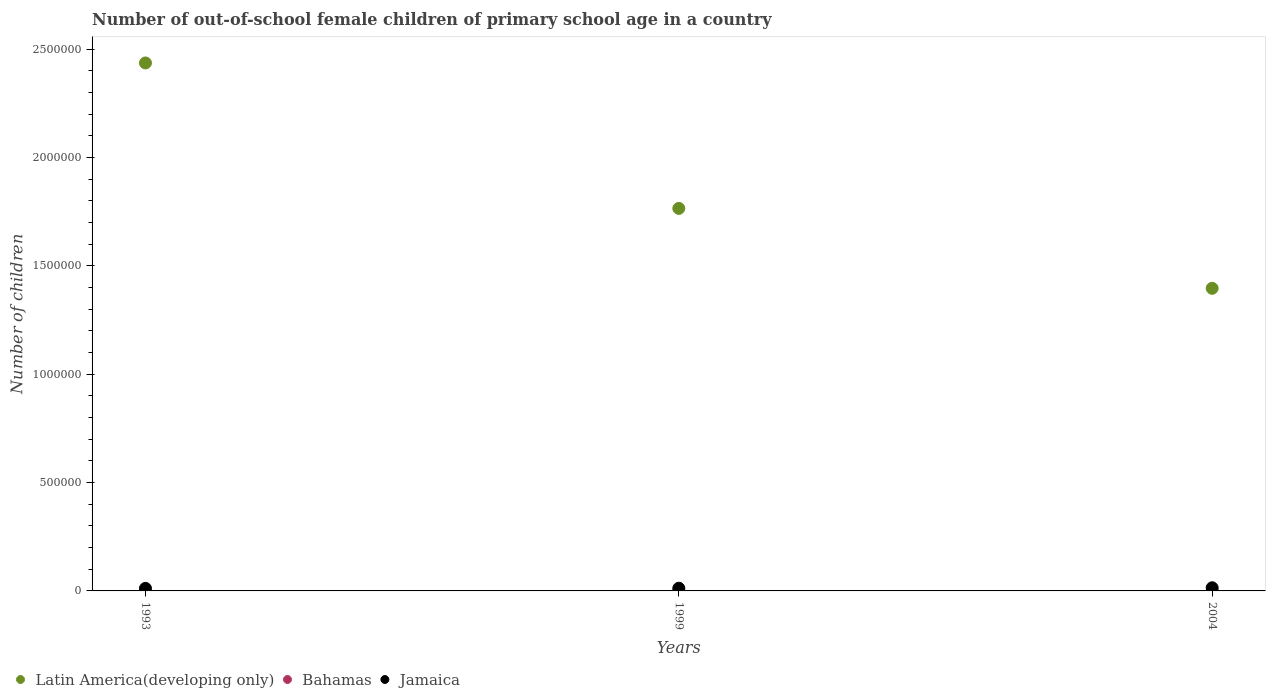Is the number of dotlines equal to the number of legend labels?
Ensure brevity in your answer.  Yes. What is the number of out-of-school female children in Bahamas in 1999?
Give a very brief answer. 1607. Across all years, what is the maximum number of out-of-school female children in Latin America(developing only)?
Make the answer very short. 2.44e+06. Across all years, what is the minimum number of out-of-school female children in Jamaica?
Offer a very short reply. 1.17e+04. What is the total number of out-of-school female children in Latin America(developing only) in the graph?
Your answer should be very brief. 5.60e+06. What is the difference between the number of out-of-school female children in Bahamas in 1993 and that in 2004?
Your response must be concise. 991. What is the difference between the number of out-of-school female children in Latin America(developing only) in 1993 and the number of out-of-school female children in Bahamas in 2004?
Offer a terse response. 2.44e+06. What is the average number of out-of-school female children in Bahamas per year?
Provide a short and direct response. 1398. In the year 1999, what is the difference between the number of out-of-school female children in Latin America(developing only) and number of out-of-school female children in Bahamas?
Provide a short and direct response. 1.76e+06. What is the ratio of the number of out-of-school female children in Latin America(developing only) in 1993 to that in 1999?
Your response must be concise. 1.38. Is the number of out-of-school female children in Latin America(developing only) in 1993 less than that in 1999?
Offer a terse response. No. What is the difference between the highest and the second highest number of out-of-school female children in Jamaica?
Your answer should be compact. 2167. What is the difference between the highest and the lowest number of out-of-school female children in Latin America(developing only)?
Ensure brevity in your answer.  1.04e+06. In how many years, is the number of out-of-school female children in Bahamas greater than the average number of out-of-school female children in Bahamas taken over all years?
Your response must be concise. 2. Is the sum of the number of out-of-school female children in Latin America(developing only) in 1993 and 1999 greater than the maximum number of out-of-school female children in Bahamas across all years?
Your answer should be very brief. Yes. What is the difference between two consecutive major ticks on the Y-axis?
Your answer should be very brief. 5.00e+05. Are the values on the major ticks of Y-axis written in scientific E-notation?
Offer a very short reply. No. Does the graph contain any zero values?
Provide a succinct answer. No. Does the graph contain grids?
Provide a short and direct response. No. How are the legend labels stacked?
Your answer should be compact. Horizontal. What is the title of the graph?
Provide a succinct answer. Number of out-of-school female children of primary school age in a country. What is the label or title of the X-axis?
Your response must be concise. Years. What is the label or title of the Y-axis?
Keep it short and to the point. Number of children. What is the Number of children in Latin America(developing only) in 1993?
Your answer should be compact. 2.44e+06. What is the Number of children of Bahamas in 1993?
Your answer should be compact. 1789. What is the Number of children in Jamaica in 1993?
Provide a short and direct response. 1.17e+04. What is the Number of children of Latin America(developing only) in 1999?
Your answer should be very brief. 1.77e+06. What is the Number of children in Bahamas in 1999?
Ensure brevity in your answer.  1607. What is the Number of children in Jamaica in 1999?
Your response must be concise. 1.24e+04. What is the Number of children in Latin America(developing only) in 2004?
Provide a short and direct response. 1.40e+06. What is the Number of children in Bahamas in 2004?
Give a very brief answer. 798. What is the Number of children in Jamaica in 2004?
Your answer should be compact. 1.46e+04. Across all years, what is the maximum Number of children of Latin America(developing only)?
Your answer should be very brief. 2.44e+06. Across all years, what is the maximum Number of children in Bahamas?
Provide a short and direct response. 1789. Across all years, what is the maximum Number of children in Jamaica?
Keep it short and to the point. 1.46e+04. Across all years, what is the minimum Number of children of Latin America(developing only)?
Provide a short and direct response. 1.40e+06. Across all years, what is the minimum Number of children in Bahamas?
Give a very brief answer. 798. Across all years, what is the minimum Number of children in Jamaica?
Your answer should be compact. 1.17e+04. What is the total Number of children of Latin America(developing only) in the graph?
Make the answer very short. 5.60e+06. What is the total Number of children of Bahamas in the graph?
Provide a short and direct response. 4194. What is the total Number of children of Jamaica in the graph?
Provide a short and direct response. 3.87e+04. What is the difference between the Number of children of Latin America(developing only) in 1993 and that in 1999?
Ensure brevity in your answer.  6.71e+05. What is the difference between the Number of children in Bahamas in 1993 and that in 1999?
Your answer should be very brief. 182. What is the difference between the Number of children in Jamaica in 1993 and that in 1999?
Provide a short and direct response. -654. What is the difference between the Number of children in Latin America(developing only) in 1993 and that in 2004?
Provide a short and direct response. 1.04e+06. What is the difference between the Number of children in Bahamas in 1993 and that in 2004?
Your answer should be very brief. 991. What is the difference between the Number of children of Jamaica in 1993 and that in 2004?
Give a very brief answer. -2821. What is the difference between the Number of children in Latin America(developing only) in 1999 and that in 2004?
Give a very brief answer. 3.69e+05. What is the difference between the Number of children in Bahamas in 1999 and that in 2004?
Offer a terse response. 809. What is the difference between the Number of children in Jamaica in 1999 and that in 2004?
Your response must be concise. -2167. What is the difference between the Number of children in Latin America(developing only) in 1993 and the Number of children in Bahamas in 1999?
Your answer should be very brief. 2.44e+06. What is the difference between the Number of children of Latin America(developing only) in 1993 and the Number of children of Jamaica in 1999?
Offer a very short reply. 2.42e+06. What is the difference between the Number of children in Bahamas in 1993 and the Number of children in Jamaica in 1999?
Your answer should be compact. -1.06e+04. What is the difference between the Number of children in Latin America(developing only) in 1993 and the Number of children in Bahamas in 2004?
Your response must be concise. 2.44e+06. What is the difference between the Number of children in Latin America(developing only) in 1993 and the Number of children in Jamaica in 2004?
Your answer should be compact. 2.42e+06. What is the difference between the Number of children in Bahamas in 1993 and the Number of children in Jamaica in 2004?
Your answer should be very brief. -1.28e+04. What is the difference between the Number of children in Latin America(developing only) in 1999 and the Number of children in Bahamas in 2004?
Provide a short and direct response. 1.76e+06. What is the difference between the Number of children of Latin America(developing only) in 1999 and the Number of children of Jamaica in 2004?
Provide a succinct answer. 1.75e+06. What is the difference between the Number of children in Bahamas in 1999 and the Number of children in Jamaica in 2004?
Your response must be concise. -1.30e+04. What is the average Number of children in Latin America(developing only) per year?
Provide a short and direct response. 1.87e+06. What is the average Number of children of Bahamas per year?
Provide a short and direct response. 1398. What is the average Number of children of Jamaica per year?
Your answer should be compact. 1.29e+04. In the year 1993, what is the difference between the Number of children of Latin America(developing only) and Number of children of Bahamas?
Provide a short and direct response. 2.44e+06. In the year 1993, what is the difference between the Number of children of Latin America(developing only) and Number of children of Jamaica?
Give a very brief answer. 2.43e+06. In the year 1993, what is the difference between the Number of children in Bahamas and Number of children in Jamaica?
Ensure brevity in your answer.  -9954. In the year 1999, what is the difference between the Number of children of Latin America(developing only) and Number of children of Bahamas?
Provide a short and direct response. 1.76e+06. In the year 1999, what is the difference between the Number of children of Latin America(developing only) and Number of children of Jamaica?
Your answer should be compact. 1.75e+06. In the year 1999, what is the difference between the Number of children in Bahamas and Number of children in Jamaica?
Offer a terse response. -1.08e+04. In the year 2004, what is the difference between the Number of children of Latin America(developing only) and Number of children of Bahamas?
Offer a terse response. 1.40e+06. In the year 2004, what is the difference between the Number of children in Latin America(developing only) and Number of children in Jamaica?
Provide a short and direct response. 1.38e+06. In the year 2004, what is the difference between the Number of children of Bahamas and Number of children of Jamaica?
Ensure brevity in your answer.  -1.38e+04. What is the ratio of the Number of children of Latin America(developing only) in 1993 to that in 1999?
Offer a very short reply. 1.38. What is the ratio of the Number of children of Bahamas in 1993 to that in 1999?
Ensure brevity in your answer.  1.11. What is the ratio of the Number of children of Jamaica in 1993 to that in 1999?
Offer a terse response. 0.95. What is the ratio of the Number of children of Latin America(developing only) in 1993 to that in 2004?
Make the answer very short. 1.74. What is the ratio of the Number of children in Bahamas in 1993 to that in 2004?
Ensure brevity in your answer.  2.24. What is the ratio of the Number of children in Jamaica in 1993 to that in 2004?
Your response must be concise. 0.81. What is the ratio of the Number of children of Latin America(developing only) in 1999 to that in 2004?
Make the answer very short. 1.26. What is the ratio of the Number of children in Bahamas in 1999 to that in 2004?
Offer a very short reply. 2.01. What is the ratio of the Number of children of Jamaica in 1999 to that in 2004?
Offer a very short reply. 0.85. What is the difference between the highest and the second highest Number of children of Latin America(developing only)?
Keep it short and to the point. 6.71e+05. What is the difference between the highest and the second highest Number of children in Bahamas?
Offer a very short reply. 182. What is the difference between the highest and the second highest Number of children in Jamaica?
Make the answer very short. 2167. What is the difference between the highest and the lowest Number of children of Latin America(developing only)?
Make the answer very short. 1.04e+06. What is the difference between the highest and the lowest Number of children in Bahamas?
Offer a very short reply. 991. What is the difference between the highest and the lowest Number of children of Jamaica?
Give a very brief answer. 2821. 